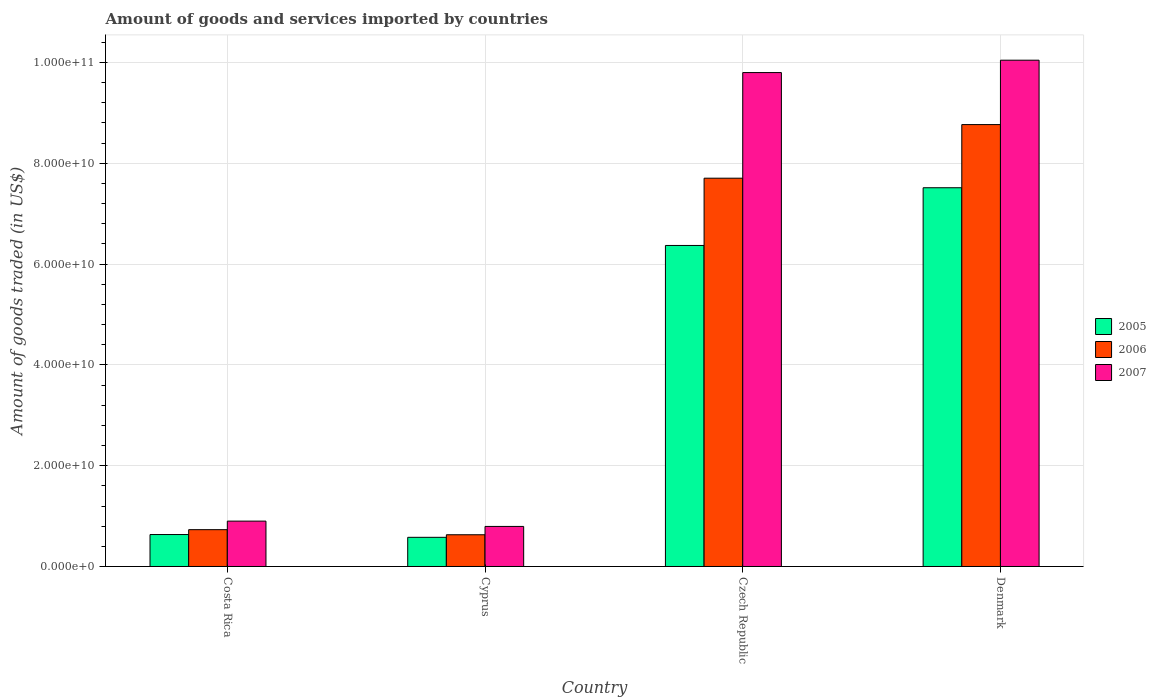Are the number of bars per tick equal to the number of legend labels?
Ensure brevity in your answer.  Yes. What is the label of the 3rd group of bars from the left?
Your answer should be very brief. Czech Republic. In how many cases, is the number of bars for a given country not equal to the number of legend labels?
Offer a very short reply. 0. What is the total amount of goods and services imported in 2005 in Cyprus?
Your answer should be very brief. 5.79e+09. Across all countries, what is the maximum total amount of goods and services imported in 2005?
Your answer should be very brief. 7.52e+1. Across all countries, what is the minimum total amount of goods and services imported in 2007?
Your answer should be compact. 7.95e+09. In which country was the total amount of goods and services imported in 2006 maximum?
Make the answer very short. Denmark. In which country was the total amount of goods and services imported in 2006 minimum?
Offer a terse response. Cyprus. What is the total total amount of goods and services imported in 2006 in the graph?
Offer a terse response. 1.78e+11. What is the difference between the total amount of goods and services imported in 2005 in Costa Rica and that in Denmark?
Your response must be concise. -6.88e+1. What is the difference between the total amount of goods and services imported in 2005 in Costa Rica and the total amount of goods and services imported in 2006 in Cyprus?
Offer a terse response. 4.10e+07. What is the average total amount of goods and services imported in 2005 per country?
Keep it short and to the point. 3.77e+1. What is the difference between the total amount of goods and services imported of/in 2006 and total amount of goods and services imported of/in 2007 in Denmark?
Ensure brevity in your answer.  -1.28e+1. What is the ratio of the total amount of goods and services imported in 2006 in Costa Rica to that in Cyprus?
Your response must be concise. 1.16. What is the difference between the highest and the second highest total amount of goods and services imported in 2007?
Ensure brevity in your answer.  9.15e+1. What is the difference between the highest and the lowest total amount of goods and services imported in 2007?
Your answer should be very brief. 9.25e+1. Is the sum of the total amount of goods and services imported in 2006 in Costa Rica and Cyprus greater than the maximum total amount of goods and services imported in 2005 across all countries?
Your answer should be very brief. No. Is it the case that in every country, the sum of the total amount of goods and services imported in 2006 and total amount of goods and services imported in 2007 is greater than the total amount of goods and services imported in 2005?
Make the answer very short. Yes. How many bars are there?
Provide a succinct answer. 12. Are all the bars in the graph horizontal?
Your answer should be very brief. No. How many countries are there in the graph?
Provide a short and direct response. 4. What is the difference between two consecutive major ticks on the Y-axis?
Offer a terse response. 2.00e+1. Are the values on the major ticks of Y-axis written in scientific E-notation?
Offer a very short reply. Yes. Does the graph contain any zero values?
Your answer should be very brief. No. How many legend labels are there?
Ensure brevity in your answer.  3. How are the legend labels stacked?
Provide a short and direct response. Vertical. What is the title of the graph?
Your response must be concise. Amount of goods and services imported by countries. Does "1966" appear as one of the legend labels in the graph?
Provide a succinct answer. No. What is the label or title of the Y-axis?
Provide a short and direct response. Amount of goods traded (in US$). What is the Amount of goods traded (in US$) of 2005 in Costa Rica?
Ensure brevity in your answer.  6.34e+09. What is the Amount of goods traded (in US$) in 2006 in Costa Rica?
Your answer should be very brief. 7.31e+09. What is the Amount of goods traded (in US$) in 2007 in Costa Rica?
Your response must be concise. 9.00e+09. What is the Amount of goods traded (in US$) of 2005 in Cyprus?
Your answer should be very brief. 5.79e+09. What is the Amount of goods traded (in US$) of 2006 in Cyprus?
Give a very brief answer. 6.30e+09. What is the Amount of goods traded (in US$) in 2007 in Cyprus?
Your answer should be compact. 7.95e+09. What is the Amount of goods traded (in US$) in 2005 in Czech Republic?
Give a very brief answer. 6.37e+1. What is the Amount of goods traded (in US$) of 2006 in Czech Republic?
Your response must be concise. 7.70e+1. What is the Amount of goods traded (in US$) in 2007 in Czech Republic?
Your answer should be very brief. 9.80e+1. What is the Amount of goods traded (in US$) in 2005 in Denmark?
Offer a terse response. 7.52e+1. What is the Amount of goods traded (in US$) of 2006 in Denmark?
Ensure brevity in your answer.  8.77e+1. What is the Amount of goods traded (in US$) of 2007 in Denmark?
Make the answer very short. 1.00e+11. Across all countries, what is the maximum Amount of goods traded (in US$) in 2005?
Make the answer very short. 7.52e+1. Across all countries, what is the maximum Amount of goods traded (in US$) in 2006?
Offer a terse response. 8.77e+1. Across all countries, what is the maximum Amount of goods traded (in US$) in 2007?
Offer a very short reply. 1.00e+11. Across all countries, what is the minimum Amount of goods traded (in US$) in 2005?
Your answer should be very brief. 5.79e+09. Across all countries, what is the minimum Amount of goods traded (in US$) in 2006?
Your answer should be very brief. 6.30e+09. Across all countries, what is the minimum Amount of goods traded (in US$) of 2007?
Offer a very short reply. 7.95e+09. What is the total Amount of goods traded (in US$) in 2005 in the graph?
Keep it short and to the point. 1.51e+11. What is the total Amount of goods traded (in US$) of 2006 in the graph?
Provide a short and direct response. 1.78e+11. What is the total Amount of goods traded (in US$) in 2007 in the graph?
Offer a terse response. 2.15e+11. What is the difference between the Amount of goods traded (in US$) of 2005 in Costa Rica and that in Cyprus?
Provide a succinct answer. 5.52e+08. What is the difference between the Amount of goods traded (in US$) of 2006 in Costa Rica and that in Cyprus?
Your answer should be compact. 1.01e+09. What is the difference between the Amount of goods traded (in US$) of 2007 in Costa Rica and that in Cyprus?
Keep it short and to the point. 1.05e+09. What is the difference between the Amount of goods traded (in US$) of 2005 in Costa Rica and that in Czech Republic?
Offer a very short reply. -5.74e+1. What is the difference between the Amount of goods traded (in US$) of 2006 in Costa Rica and that in Czech Republic?
Give a very brief answer. -6.97e+1. What is the difference between the Amount of goods traded (in US$) of 2007 in Costa Rica and that in Czech Republic?
Your answer should be very brief. -8.90e+1. What is the difference between the Amount of goods traded (in US$) of 2005 in Costa Rica and that in Denmark?
Offer a terse response. -6.88e+1. What is the difference between the Amount of goods traded (in US$) in 2006 in Costa Rica and that in Denmark?
Ensure brevity in your answer.  -8.04e+1. What is the difference between the Amount of goods traded (in US$) in 2007 in Costa Rica and that in Denmark?
Offer a very short reply. -9.15e+1. What is the difference between the Amount of goods traded (in US$) in 2005 in Cyprus and that in Czech Republic?
Provide a short and direct response. -5.79e+1. What is the difference between the Amount of goods traded (in US$) of 2006 in Cyprus and that in Czech Republic?
Make the answer very short. -7.08e+1. What is the difference between the Amount of goods traded (in US$) in 2007 in Cyprus and that in Czech Republic?
Provide a succinct answer. -9.01e+1. What is the difference between the Amount of goods traded (in US$) of 2005 in Cyprus and that in Denmark?
Ensure brevity in your answer.  -6.94e+1. What is the difference between the Amount of goods traded (in US$) in 2006 in Cyprus and that in Denmark?
Your response must be concise. -8.14e+1. What is the difference between the Amount of goods traded (in US$) of 2007 in Cyprus and that in Denmark?
Keep it short and to the point. -9.25e+1. What is the difference between the Amount of goods traded (in US$) in 2005 in Czech Republic and that in Denmark?
Your answer should be compact. -1.15e+1. What is the difference between the Amount of goods traded (in US$) in 2006 in Czech Republic and that in Denmark?
Your answer should be very brief. -1.06e+1. What is the difference between the Amount of goods traded (in US$) in 2007 in Czech Republic and that in Denmark?
Provide a succinct answer. -2.46e+09. What is the difference between the Amount of goods traded (in US$) in 2005 in Costa Rica and the Amount of goods traded (in US$) in 2006 in Cyprus?
Offer a very short reply. 4.10e+07. What is the difference between the Amount of goods traded (in US$) in 2005 in Costa Rica and the Amount of goods traded (in US$) in 2007 in Cyprus?
Provide a succinct answer. -1.61e+09. What is the difference between the Amount of goods traded (in US$) in 2006 in Costa Rica and the Amount of goods traded (in US$) in 2007 in Cyprus?
Provide a short and direct response. -6.41e+08. What is the difference between the Amount of goods traded (in US$) of 2005 in Costa Rica and the Amount of goods traded (in US$) of 2006 in Czech Republic?
Give a very brief answer. -7.07e+1. What is the difference between the Amount of goods traded (in US$) in 2005 in Costa Rica and the Amount of goods traded (in US$) in 2007 in Czech Republic?
Your answer should be compact. -9.17e+1. What is the difference between the Amount of goods traded (in US$) in 2006 in Costa Rica and the Amount of goods traded (in US$) in 2007 in Czech Republic?
Make the answer very short. -9.07e+1. What is the difference between the Amount of goods traded (in US$) of 2005 in Costa Rica and the Amount of goods traded (in US$) of 2006 in Denmark?
Your response must be concise. -8.13e+1. What is the difference between the Amount of goods traded (in US$) of 2005 in Costa Rica and the Amount of goods traded (in US$) of 2007 in Denmark?
Offer a terse response. -9.41e+1. What is the difference between the Amount of goods traded (in US$) of 2006 in Costa Rica and the Amount of goods traded (in US$) of 2007 in Denmark?
Offer a very short reply. -9.32e+1. What is the difference between the Amount of goods traded (in US$) in 2005 in Cyprus and the Amount of goods traded (in US$) in 2006 in Czech Republic?
Offer a terse response. -7.13e+1. What is the difference between the Amount of goods traded (in US$) in 2005 in Cyprus and the Amount of goods traded (in US$) in 2007 in Czech Republic?
Your response must be concise. -9.22e+1. What is the difference between the Amount of goods traded (in US$) of 2006 in Cyprus and the Amount of goods traded (in US$) of 2007 in Czech Republic?
Your answer should be compact. -9.17e+1. What is the difference between the Amount of goods traded (in US$) in 2005 in Cyprus and the Amount of goods traded (in US$) in 2006 in Denmark?
Provide a succinct answer. -8.19e+1. What is the difference between the Amount of goods traded (in US$) in 2005 in Cyprus and the Amount of goods traded (in US$) in 2007 in Denmark?
Your answer should be very brief. -9.47e+1. What is the difference between the Amount of goods traded (in US$) of 2006 in Cyprus and the Amount of goods traded (in US$) of 2007 in Denmark?
Keep it short and to the point. -9.42e+1. What is the difference between the Amount of goods traded (in US$) in 2005 in Czech Republic and the Amount of goods traded (in US$) in 2006 in Denmark?
Make the answer very short. -2.40e+1. What is the difference between the Amount of goods traded (in US$) of 2005 in Czech Republic and the Amount of goods traded (in US$) of 2007 in Denmark?
Your answer should be very brief. -3.68e+1. What is the difference between the Amount of goods traded (in US$) in 2006 in Czech Republic and the Amount of goods traded (in US$) in 2007 in Denmark?
Give a very brief answer. -2.34e+1. What is the average Amount of goods traded (in US$) of 2005 per country?
Provide a short and direct response. 3.77e+1. What is the average Amount of goods traded (in US$) in 2006 per country?
Keep it short and to the point. 4.46e+1. What is the average Amount of goods traded (in US$) of 2007 per country?
Keep it short and to the point. 5.39e+1. What is the difference between the Amount of goods traded (in US$) of 2005 and Amount of goods traded (in US$) of 2006 in Costa Rica?
Your answer should be compact. -9.69e+08. What is the difference between the Amount of goods traded (in US$) in 2005 and Amount of goods traded (in US$) in 2007 in Costa Rica?
Offer a very short reply. -2.66e+09. What is the difference between the Amount of goods traded (in US$) of 2006 and Amount of goods traded (in US$) of 2007 in Costa Rica?
Your response must be concise. -1.69e+09. What is the difference between the Amount of goods traded (in US$) of 2005 and Amount of goods traded (in US$) of 2006 in Cyprus?
Keep it short and to the point. -5.11e+08. What is the difference between the Amount of goods traded (in US$) in 2005 and Amount of goods traded (in US$) in 2007 in Cyprus?
Offer a very short reply. -2.16e+09. What is the difference between the Amount of goods traded (in US$) of 2006 and Amount of goods traded (in US$) of 2007 in Cyprus?
Ensure brevity in your answer.  -1.65e+09. What is the difference between the Amount of goods traded (in US$) in 2005 and Amount of goods traded (in US$) in 2006 in Czech Republic?
Provide a succinct answer. -1.33e+1. What is the difference between the Amount of goods traded (in US$) of 2005 and Amount of goods traded (in US$) of 2007 in Czech Republic?
Your response must be concise. -3.43e+1. What is the difference between the Amount of goods traded (in US$) of 2006 and Amount of goods traded (in US$) of 2007 in Czech Republic?
Your response must be concise. -2.10e+1. What is the difference between the Amount of goods traded (in US$) of 2005 and Amount of goods traded (in US$) of 2006 in Denmark?
Provide a succinct answer. -1.25e+1. What is the difference between the Amount of goods traded (in US$) of 2005 and Amount of goods traded (in US$) of 2007 in Denmark?
Your response must be concise. -2.53e+1. What is the difference between the Amount of goods traded (in US$) of 2006 and Amount of goods traded (in US$) of 2007 in Denmark?
Offer a very short reply. -1.28e+1. What is the ratio of the Amount of goods traded (in US$) in 2005 in Costa Rica to that in Cyprus?
Ensure brevity in your answer.  1.1. What is the ratio of the Amount of goods traded (in US$) of 2006 in Costa Rica to that in Cyprus?
Your response must be concise. 1.16. What is the ratio of the Amount of goods traded (in US$) of 2007 in Costa Rica to that in Cyprus?
Offer a terse response. 1.13. What is the ratio of the Amount of goods traded (in US$) of 2005 in Costa Rica to that in Czech Republic?
Offer a very short reply. 0.1. What is the ratio of the Amount of goods traded (in US$) in 2006 in Costa Rica to that in Czech Republic?
Keep it short and to the point. 0.09. What is the ratio of the Amount of goods traded (in US$) of 2007 in Costa Rica to that in Czech Republic?
Offer a very short reply. 0.09. What is the ratio of the Amount of goods traded (in US$) of 2005 in Costa Rica to that in Denmark?
Make the answer very short. 0.08. What is the ratio of the Amount of goods traded (in US$) in 2006 in Costa Rica to that in Denmark?
Ensure brevity in your answer.  0.08. What is the ratio of the Amount of goods traded (in US$) in 2007 in Costa Rica to that in Denmark?
Provide a short and direct response. 0.09. What is the ratio of the Amount of goods traded (in US$) of 2005 in Cyprus to that in Czech Republic?
Provide a succinct answer. 0.09. What is the ratio of the Amount of goods traded (in US$) in 2006 in Cyprus to that in Czech Republic?
Provide a succinct answer. 0.08. What is the ratio of the Amount of goods traded (in US$) in 2007 in Cyprus to that in Czech Republic?
Give a very brief answer. 0.08. What is the ratio of the Amount of goods traded (in US$) of 2005 in Cyprus to that in Denmark?
Keep it short and to the point. 0.08. What is the ratio of the Amount of goods traded (in US$) of 2006 in Cyprus to that in Denmark?
Ensure brevity in your answer.  0.07. What is the ratio of the Amount of goods traded (in US$) of 2007 in Cyprus to that in Denmark?
Provide a succinct answer. 0.08. What is the ratio of the Amount of goods traded (in US$) in 2005 in Czech Republic to that in Denmark?
Provide a succinct answer. 0.85. What is the ratio of the Amount of goods traded (in US$) in 2006 in Czech Republic to that in Denmark?
Offer a very short reply. 0.88. What is the ratio of the Amount of goods traded (in US$) of 2007 in Czech Republic to that in Denmark?
Provide a short and direct response. 0.98. What is the difference between the highest and the second highest Amount of goods traded (in US$) of 2005?
Ensure brevity in your answer.  1.15e+1. What is the difference between the highest and the second highest Amount of goods traded (in US$) in 2006?
Ensure brevity in your answer.  1.06e+1. What is the difference between the highest and the second highest Amount of goods traded (in US$) of 2007?
Keep it short and to the point. 2.46e+09. What is the difference between the highest and the lowest Amount of goods traded (in US$) in 2005?
Ensure brevity in your answer.  6.94e+1. What is the difference between the highest and the lowest Amount of goods traded (in US$) of 2006?
Provide a short and direct response. 8.14e+1. What is the difference between the highest and the lowest Amount of goods traded (in US$) of 2007?
Your answer should be compact. 9.25e+1. 